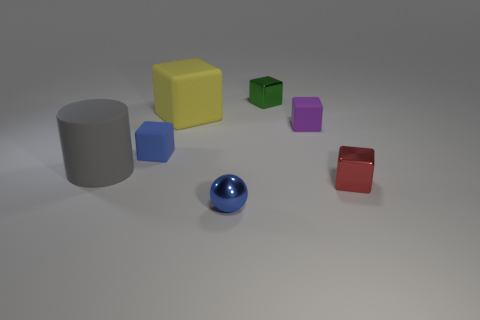How many other small things have the same shape as the small purple rubber object?
Make the answer very short. 3. What size is the matte block that is on the right side of the blue object that is in front of the big matte cylinder?
Ensure brevity in your answer.  Small. What number of yellow things are rubber things or tiny metallic balls?
Offer a terse response. 1. Are there fewer green things that are in front of the small red block than yellow matte blocks in front of the blue shiny object?
Give a very brief answer. No. Do the red metallic cube and the block that is behind the yellow block have the same size?
Offer a terse response. Yes. How many other rubber objects have the same size as the gray matte object?
Offer a very short reply. 1. What number of big objects are blue things or purple matte cubes?
Your answer should be very brief. 0. Are any cyan shiny spheres visible?
Make the answer very short. No. Is the number of tiny blue spheres behind the red shiny thing greater than the number of small blocks in front of the large matte block?
Make the answer very short. No. There is a small block to the left of the big rubber object right of the blue rubber block; what is its color?
Your answer should be very brief. Blue. 